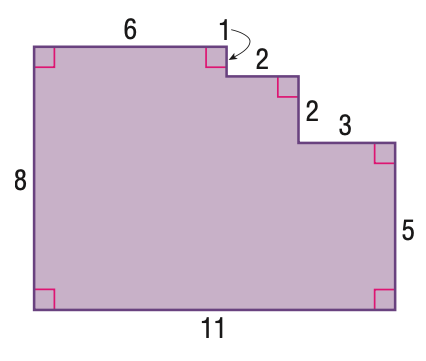Question: Find the area of the figure.
Choices:
A. 73
B. 77
C. 80
D. 88
Answer with the letter. Answer: B 